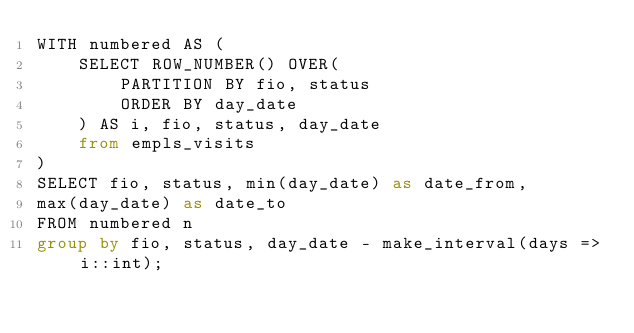<code> <loc_0><loc_0><loc_500><loc_500><_SQL_>WITH numbered AS (
    SELECT ROW_NUMBER() OVER(
        PARTITION BY fio, status
        ORDER BY day_date
    ) AS i, fio, status, day_date
    from empls_visits
)
SELECT fio, status, min(day_date) as date_from,
max(day_date) as date_to
FROM numbered n
group by fio, status, day_date - make_interval(days => i::int);
</code> 